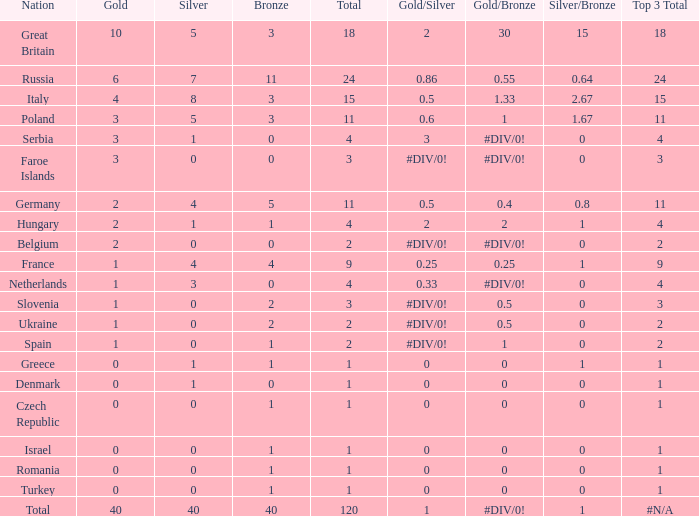What Nation has a Gold entry that is greater than 0, a Total that is greater than 2, a Silver entry that is larger than 1, and 0 Bronze? Netherlands. 